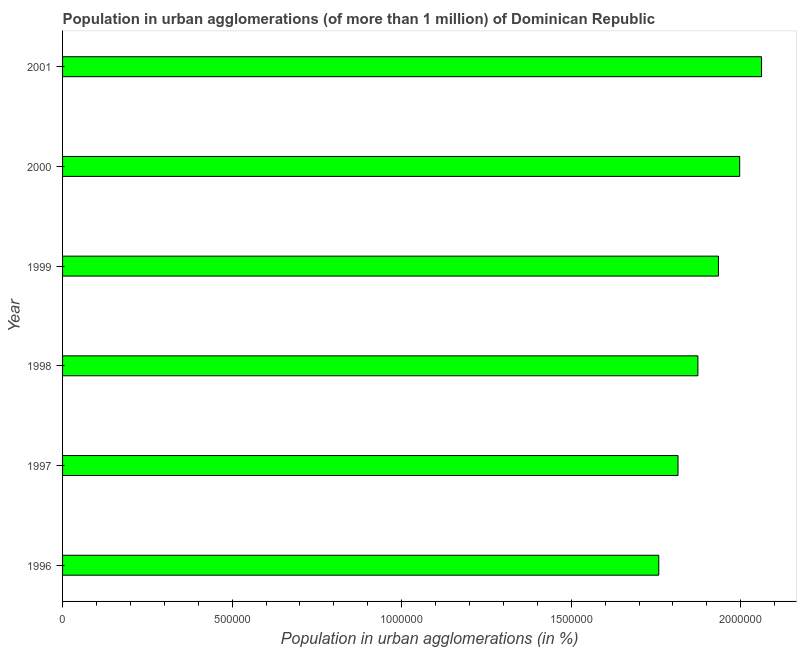Does the graph contain grids?
Make the answer very short. No. What is the title of the graph?
Your answer should be compact. Population in urban agglomerations (of more than 1 million) of Dominican Republic. What is the label or title of the X-axis?
Your answer should be compact. Population in urban agglomerations (in %). What is the population in urban agglomerations in 1996?
Your answer should be compact. 1.76e+06. Across all years, what is the maximum population in urban agglomerations?
Your answer should be very brief. 2.06e+06. Across all years, what is the minimum population in urban agglomerations?
Your answer should be very brief. 1.76e+06. In which year was the population in urban agglomerations maximum?
Offer a very short reply. 2001. In which year was the population in urban agglomerations minimum?
Provide a short and direct response. 1996. What is the sum of the population in urban agglomerations?
Offer a terse response. 1.14e+07. What is the difference between the population in urban agglomerations in 1996 and 1998?
Offer a terse response. -1.15e+05. What is the average population in urban agglomerations per year?
Give a very brief answer. 1.91e+06. What is the median population in urban agglomerations?
Offer a terse response. 1.90e+06. Do a majority of the years between 2001 and 1996 (inclusive) have population in urban agglomerations greater than 1500000 %?
Your answer should be compact. Yes. What is the ratio of the population in urban agglomerations in 1998 to that in 2001?
Provide a short and direct response. 0.91. What is the difference between the highest and the second highest population in urban agglomerations?
Provide a succinct answer. 6.45e+04. Is the sum of the population in urban agglomerations in 1998 and 2000 greater than the maximum population in urban agglomerations across all years?
Your response must be concise. Yes. What is the difference between the highest and the lowest population in urban agglomerations?
Offer a very short reply. 3.03e+05. In how many years, is the population in urban agglomerations greater than the average population in urban agglomerations taken over all years?
Give a very brief answer. 3. Are all the bars in the graph horizontal?
Your answer should be compact. Yes. How many years are there in the graph?
Your answer should be very brief. 6. Are the values on the major ticks of X-axis written in scientific E-notation?
Your answer should be compact. No. What is the Population in urban agglomerations (in %) in 1996?
Give a very brief answer. 1.76e+06. What is the Population in urban agglomerations (in %) in 1997?
Ensure brevity in your answer.  1.81e+06. What is the Population in urban agglomerations (in %) of 1998?
Your answer should be very brief. 1.87e+06. What is the Population in urban agglomerations (in %) in 1999?
Offer a terse response. 1.93e+06. What is the Population in urban agglomerations (in %) in 2000?
Provide a short and direct response. 2.00e+06. What is the Population in urban agglomerations (in %) of 2001?
Give a very brief answer. 2.06e+06. What is the difference between the Population in urban agglomerations (in %) in 1996 and 1997?
Make the answer very short. -5.68e+04. What is the difference between the Population in urban agglomerations (in %) in 1996 and 1998?
Keep it short and to the point. -1.15e+05. What is the difference between the Population in urban agglomerations (in %) in 1996 and 1999?
Keep it short and to the point. -1.76e+05. What is the difference between the Population in urban agglomerations (in %) in 1996 and 2000?
Keep it short and to the point. -2.39e+05. What is the difference between the Population in urban agglomerations (in %) in 1996 and 2001?
Keep it short and to the point. -3.03e+05. What is the difference between the Population in urban agglomerations (in %) in 1997 and 1998?
Your answer should be compact. -5.87e+04. What is the difference between the Population in urban agglomerations (in %) in 1997 and 1999?
Offer a very short reply. -1.19e+05. What is the difference between the Population in urban agglomerations (in %) in 1997 and 2000?
Your answer should be compact. -1.82e+05. What is the difference between the Population in urban agglomerations (in %) in 1997 and 2001?
Give a very brief answer. -2.46e+05. What is the difference between the Population in urban agglomerations (in %) in 1998 and 1999?
Offer a very short reply. -6.06e+04. What is the difference between the Population in urban agglomerations (in %) in 1998 and 2000?
Offer a terse response. -1.23e+05. What is the difference between the Population in urban agglomerations (in %) in 1998 and 2001?
Ensure brevity in your answer.  -1.88e+05. What is the difference between the Population in urban agglomerations (in %) in 1999 and 2000?
Your answer should be compact. -6.26e+04. What is the difference between the Population in urban agglomerations (in %) in 1999 and 2001?
Your answer should be very brief. -1.27e+05. What is the difference between the Population in urban agglomerations (in %) in 2000 and 2001?
Provide a short and direct response. -6.45e+04. What is the ratio of the Population in urban agglomerations (in %) in 1996 to that in 1997?
Your response must be concise. 0.97. What is the ratio of the Population in urban agglomerations (in %) in 1996 to that in 1998?
Make the answer very short. 0.94. What is the ratio of the Population in urban agglomerations (in %) in 1996 to that in 1999?
Provide a succinct answer. 0.91. What is the ratio of the Population in urban agglomerations (in %) in 1996 to that in 2000?
Offer a very short reply. 0.88. What is the ratio of the Population in urban agglomerations (in %) in 1996 to that in 2001?
Your response must be concise. 0.85. What is the ratio of the Population in urban agglomerations (in %) in 1997 to that in 1998?
Give a very brief answer. 0.97. What is the ratio of the Population in urban agglomerations (in %) in 1997 to that in 1999?
Ensure brevity in your answer.  0.94. What is the ratio of the Population in urban agglomerations (in %) in 1997 to that in 2000?
Provide a succinct answer. 0.91. What is the ratio of the Population in urban agglomerations (in %) in 1998 to that in 2000?
Offer a terse response. 0.94. What is the ratio of the Population in urban agglomerations (in %) in 1998 to that in 2001?
Provide a short and direct response. 0.91. What is the ratio of the Population in urban agglomerations (in %) in 1999 to that in 2000?
Provide a succinct answer. 0.97. What is the ratio of the Population in urban agglomerations (in %) in 1999 to that in 2001?
Your answer should be compact. 0.94. 